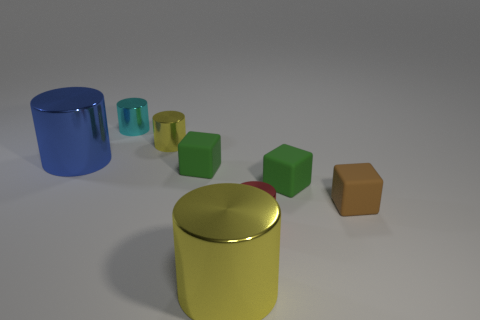Are there any yellow cylinders right of the tiny yellow cylinder?
Give a very brief answer. Yes. There is a tiny rubber cube that is to the left of the tiny green rubber thing to the right of the small red metallic cylinder; is there a cube that is on the right side of it?
Provide a short and direct response. Yes. Does the yellow metal object in front of the small brown cube have the same shape as the red thing?
Ensure brevity in your answer.  Yes. What is the color of the big cylinder that is made of the same material as the blue thing?
Provide a succinct answer. Yellow. What number of small yellow objects are the same material as the small cyan object?
Keep it short and to the point. 1. What is the color of the big cylinder that is behind the brown cube that is to the right of the yellow shiny object that is in front of the tiny yellow shiny object?
Offer a very short reply. Blue. Do the red cylinder and the brown cube have the same size?
Provide a short and direct response. Yes. How many objects are cylinders behind the big yellow thing or tiny green rubber cylinders?
Make the answer very short. 4. Is the tiny yellow thing the same shape as the red metallic object?
Give a very brief answer. Yes. What number of other objects are there of the same size as the cyan shiny cylinder?
Provide a succinct answer. 5. 